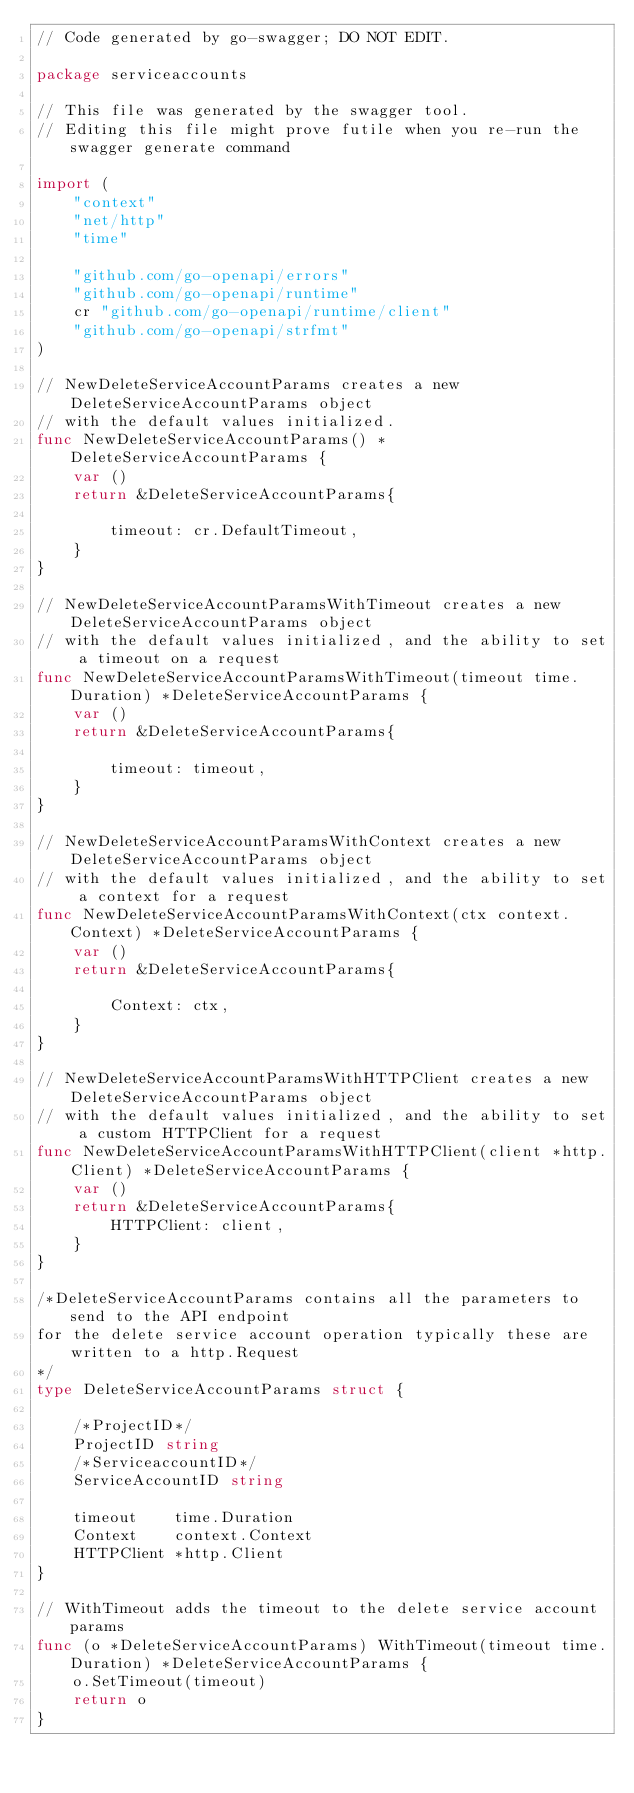<code> <loc_0><loc_0><loc_500><loc_500><_Go_>// Code generated by go-swagger; DO NOT EDIT.

package serviceaccounts

// This file was generated by the swagger tool.
// Editing this file might prove futile when you re-run the swagger generate command

import (
	"context"
	"net/http"
	"time"

	"github.com/go-openapi/errors"
	"github.com/go-openapi/runtime"
	cr "github.com/go-openapi/runtime/client"
	"github.com/go-openapi/strfmt"
)

// NewDeleteServiceAccountParams creates a new DeleteServiceAccountParams object
// with the default values initialized.
func NewDeleteServiceAccountParams() *DeleteServiceAccountParams {
	var ()
	return &DeleteServiceAccountParams{

		timeout: cr.DefaultTimeout,
	}
}

// NewDeleteServiceAccountParamsWithTimeout creates a new DeleteServiceAccountParams object
// with the default values initialized, and the ability to set a timeout on a request
func NewDeleteServiceAccountParamsWithTimeout(timeout time.Duration) *DeleteServiceAccountParams {
	var ()
	return &DeleteServiceAccountParams{

		timeout: timeout,
	}
}

// NewDeleteServiceAccountParamsWithContext creates a new DeleteServiceAccountParams object
// with the default values initialized, and the ability to set a context for a request
func NewDeleteServiceAccountParamsWithContext(ctx context.Context) *DeleteServiceAccountParams {
	var ()
	return &DeleteServiceAccountParams{

		Context: ctx,
	}
}

// NewDeleteServiceAccountParamsWithHTTPClient creates a new DeleteServiceAccountParams object
// with the default values initialized, and the ability to set a custom HTTPClient for a request
func NewDeleteServiceAccountParamsWithHTTPClient(client *http.Client) *DeleteServiceAccountParams {
	var ()
	return &DeleteServiceAccountParams{
		HTTPClient: client,
	}
}

/*DeleteServiceAccountParams contains all the parameters to send to the API endpoint
for the delete service account operation typically these are written to a http.Request
*/
type DeleteServiceAccountParams struct {

	/*ProjectID*/
	ProjectID string
	/*ServiceaccountID*/
	ServiceAccountID string

	timeout    time.Duration
	Context    context.Context
	HTTPClient *http.Client
}

// WithTimeout adds the timeout to the delete service account params
func (o *DeleteServiceAccountParams) WithTimeout(timeout time.Duration) *DeleteServiceAccountParams {
	o.SetTimeout(timeout)
	return o
}
</code> 